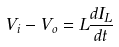<formula> <loc_0><loc_0><loc_500><loc_500>V _ { i } - V _ { o } = L \frac { d I _ { L } } { d t }</formula> 